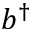Convert formula to latex. <formula><loc_0><loc_0><loc_500><loc_500>b ^ { \dagger }</formula> 